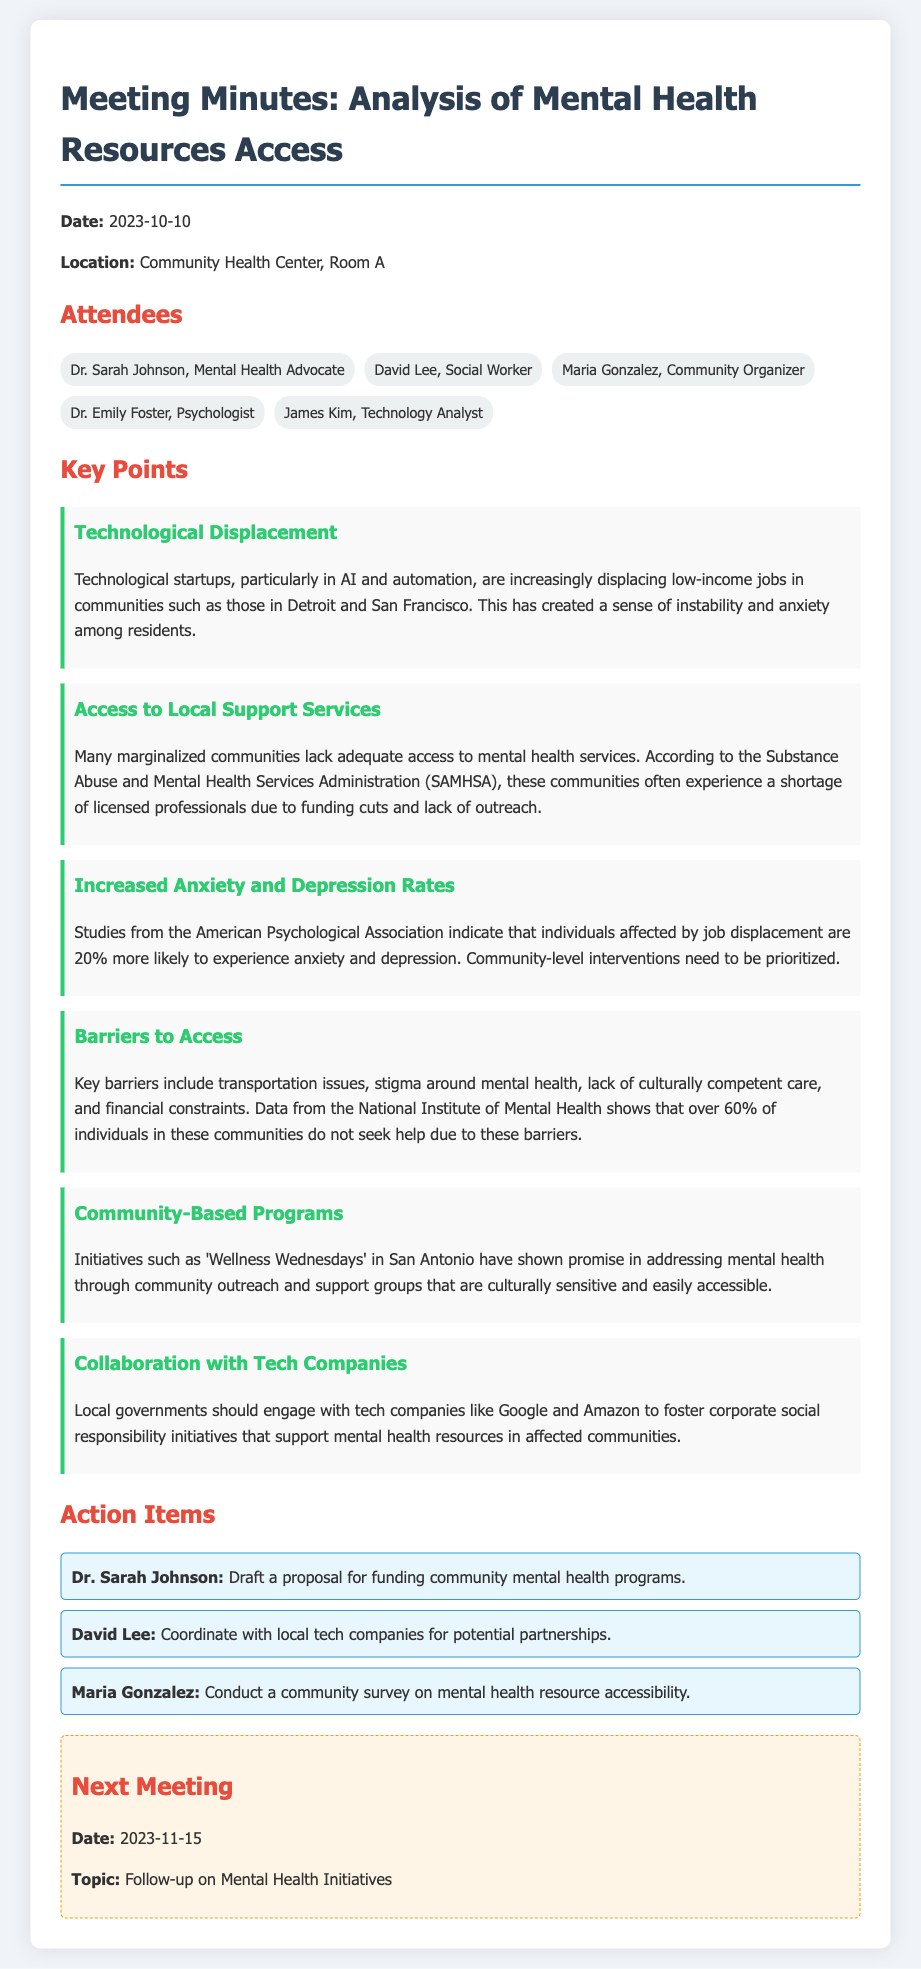What is the date of the meeting? The date of the meeting is listed prominently at the top of the document, which is 2023-10-10.
Answer: 2023-10-10 Who is the psychologist attending the meeting? The psychologist attending the meeting is mentioned in the list of attendees as Dr. Emily Foster.
Answer: Dr. Emily Foster What percentage of individuals in communities do not seek help due to barriers? The document states that over 60% of individuals in these communities do not seek help, according to the National Institute of Mental Health.
Answer: over 60% What initiative is mentioned as successfully addressing mental health in San Antonio? One specific initiative mentioned is 'Wellness Wednesdays' that is focused on community outreach and support groups.
Answer: 'Wellness Wednesdays' What is one key barrier to accessing mental health services listed in the document? The document outlines several barriers, and one of them is stigma around mental health.
Answer: stigma around mental health What is the topic of the next meeting? The topic for the next meeting is stated in the document as a follow-up on mental health initiatives.
Answer: Follow-up on Mental Health Initiatives Who is responsible for drafting a proposal for funding community mental health programs? The action item indicates that Dr. Sarah Johnson is responsible for this task.
Answer: Dr. Sarah Johnson What city is specifically mentioned as being affected by job displacement? The document specifies Detroit as a city affected by technological displacement and low-income job losses.
Answer: Detroit 